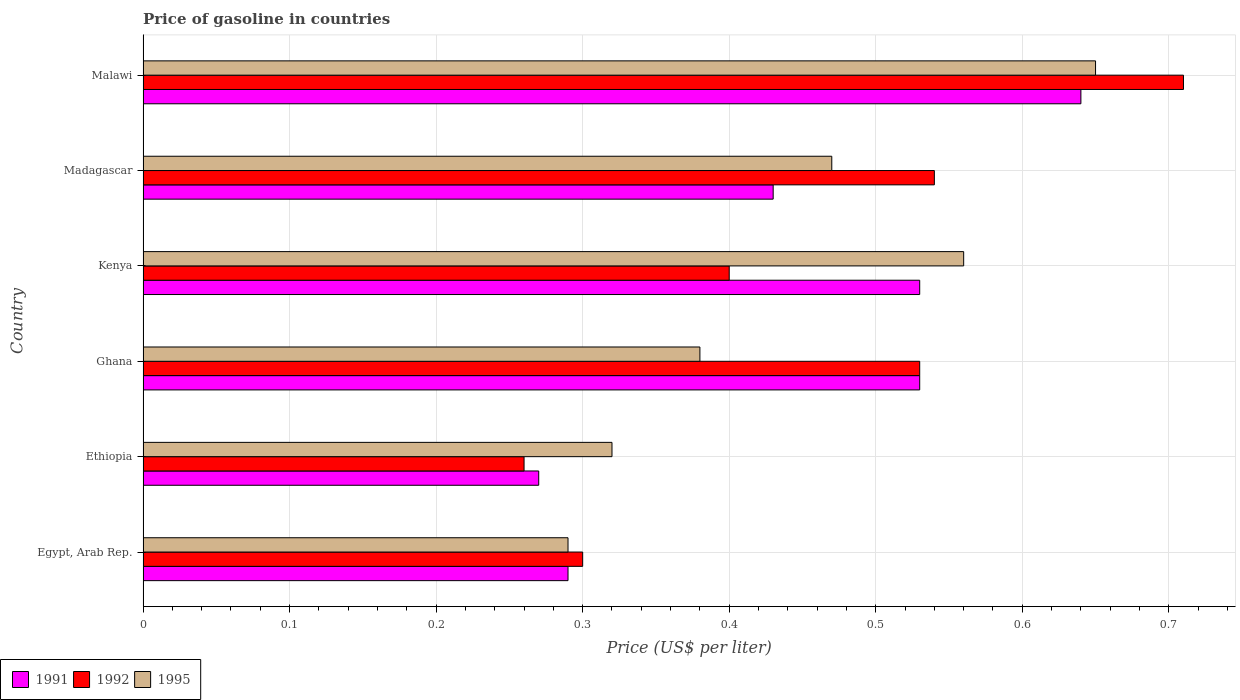How many different coloured bars are there?
Provide a short and direct response. 3. Are the number of bars per tick equal to the number of legend labels?
Provide a succinct answer. Yes. What is the label of the 5th group of bars from the top?
Provide a short and direct response. Ethiopia. In how many cases, is the number of bars for a given country not equal to the number of legend labels?
Provide a short and direct response. 0. What is the price of gasoline in 1991 in Kenya?
Your answer should be compact. 0.53. Across all countries, what is the maximum price of gasoline in 1992?
Ensure brevity in your answer.  0.71. Across all countries, what is the minimum price of gasoline in 1991?
Give a very brief answer. 0.27. In which country was the price of gasoline in 1991 maximum?
Your answer should be compact. Malawi. In which country was the price of gasoline in 1995 minimum?
Your answer should be very brief. Egypt, Arab Rep. What is the total price of gasoline in 1995 in the graph?
Provide a succinct answer. 2.67. What is the difference between the price of gasoline in 1991 in Egypt, Arab Rep. and that in Ethiopia?
Your response must be concise. 0.02. What is the difference between the price of gasoline in 1991 in Kenya and the price of gasoline in 1992 in Madagascar?
Your response must be concise. -0.01. What is the average price of gasoline in 1992 per country?
Provide a short and direct response. 0.46. What is the difference between the price of gasoline in 1991 and price of gasoline in 1992 in Ghana?
Give a very brief answer. 0. In how many countries, is the price of gasoline in 1992 greater than 0.52 US$?
Your answer should be compact. 3. What is the ratio of the price of gasoline in 1995 in Egypt, Arab Rep. to that in Ghana?
Your response must be concise. 0.76. Is the difference between the price of gasoline in 1991 in Kenya and Madagascar greater than the difference between the price of gasoline in 1992 in Kenya and Madagascar?
Keep it short and to the point. Yes. What is the difference between the highest and the second highest price of gasoline in 1991?
Ensure brevity in your answer.  0.11. What is the difference between the highest and the lowest price of gasoline in 1992?
Your answer should be compact. 0.45. What does the 3rd bar from the bottom in Ethiopia represents?
Ensure brevity in your answer.  1995. Are all the bars in the graph horizontal?
Ensure brevity in your answer.  Yes. What is the difference between two consecutive major ticks on the X-axis?
Provide a succinct answer. 0.1. Does the graph contain any zero values?
Keep it short and to the point. No. Where does the legend appear in the graph?
Make the answer very short. Bottom left. How many legend labels are there?
Provide a succinct answer. 3. How are the legend labels stacked?
Keep it short and to the point. Horizontal. What is the title of the graph?
Your response must be concise. Price of gasoline in countries. What is the label or title of the X-axis?
Provide a succinct answer. Price (US$ per liter). What is the Price (US$ per liter) of 1991 in Egypt, Arab Rep.?
Your answer should be very brief. 0.29. What is the Price (US$ per liter) in 1992 in Egypt, Arab Rep.?
Offer a terse response. 0.3. What is the Price (US$ per liter) of 1995 in Egypt, Arab Rep.?
Provide a short and direct response. 0.29. What is the Price (US$ per liter) in 1991 in Ethiopia?
Ensure brevity in your answer.  0.27. What is the Price (US$ per liter) in 1992 in Ethiopia?
Offer a terse response. 0.26. What is the Price (US$ per liter) of 1995 in Ethiopia?
Offer a very short reply. 0.32. What is the Price (US$ per liter) of 1991 in Ghana?
Keep it short and to the point. 0.53. What is the Price (US$ per liter) in 1992 in Ghana?
Provide a short and direct response. 0.53. What is the Price (US$ per liter) in 1995 in Ghana?
Your answer should be compact. 0.38. What is the Price (US$ per liter) of 1991 in Kenya?
Offer a very short reply. 0.53. What is the Price (US$ per liter) in 1992 in Kenya?
Your answer should be compact. 0.4. What is the Price (US$ per liter) of 1995 in Kenya?
Provide a succinct answer. 0.56. What is the Price (US$ per liter) of 1991 in Madagascar?
Provide a short and direct response. 0.43. What is the Price (US$ per liter) of 1992 in Madagascar?
Provide a short and direct response. 0.54. What is the Price (US$ per liter) of 1995 in Madagascar?
Offer a terse response. 0.47. What is the Price (US$ per liter) in 1991 in Malawi?
Ensure brevity in your answer.  0.64. What is the Price (US$ per liter) in 1992 in Malawi?
Keep it short and to the point. 0.71. What is the Price (US$ per liter) in 1995 in Malawi?
Your answer should be very brief. 0.65. Across all countries, what is the maximum Price (US$ per liter) in 1991?
Give a very brief answer. 0.64. Across all countries, what is the maximum Price (US$ per liter) in 1992?
Keep it short and to the point. 0.71. Across all countries, what is the maximum Price (US$ per liter) in 1995?
Provide a short and direct response. 0.65. Across all countries, what is the minimum Price (US$ per liter) of 1991?
Offer a very short reply. 0.27. Across all countries, what is the minimum Price (US$ per liter) in 1992?
Keep it short and to the point. 0.26. Across all countries, what is the minimum Price (US$ per liter) in 1995?
Offer a very short reply. 0.29. What is the total Price (US$ per liter) in 1991 in the graph?
Your answer should be very brief. 2.69. What is the total Price (US$ per liter) in 1992 in the graph?
Your response must be concise. 2.74. What is the total Price (US$ per liter) in 1995 in the graph?
Offer a very short reply. 2.67. What is the difference between the Price (US$ per liter) of 1992 in Egypt, Arab Rep. and that in Ethiopia?
Your response must be concise. 0.04. What is the difference between the Price (US$ per liter) of 1995 in Egypt, Arab Rep. and that in Ethiopia?
Give a very brief answer. -0.03. What is the difference between the Price (US$ per liter) in 1991 in Egypt, Arab Rep. and that in Ghana?
Offer a very short reply. -0.24. What is the difference between the Price (US$ per liter) in 1992 in Egypt, Arab Rep. and that in Ghana?
Offer a very short reply. -0.23. What is the difference between the Price (US$ per liter) in 1995 in Egypt, Arab Rep. and that in Ghana?
Your answer should be very brief. -0.09. What is the difference between the Price (US$ per liter) of 1991 in Egypt, Arab Rep. and that in Kenya?
Your answer should be compact. -0.24. What is the difference between the Price (US$ per liter) in 1992 in Egypt, Arab Rep. and that in Kenya?
Make the answer very short. -0.1. What is the difference between the Price (US$ per liter) in 1995 in Egypt, Arab Rep. and that in Kenya?
Offer a terse response. -0.27. What is the difference between the Price (US$ per liter) in 1991 in Egypt, Arab Rep. and that in Madagascar?
Provide a succinct answer. -0.14. What is the difference between the Price (US$ per liter) of 1992 in Egypt, Arab Rep. and that in Madagascar?
Make the answer very short. -0.24. What is the difference between the Price (US$ per liter) in 1995 in Egypt, Arab Rep. and that in Madagascar?
Offer a terse response. -0.18. What is the difference between the Price (US$ per liter) of 1991 in Egypt, Arab Rep. and that in Malawi?
Your response must be concise. -0.35. What is the difference between the Price (US$ per liter) in 1992 in Egypt, Arab Rep. and that in Malawi?
Make the answer very short. -0.41. What is the difference between the Price (US$ per liter) in 1995 in Egypt, Arab Rep. and that in Malawi?
Give a very brief answer. -0.36. What is the difference between the Price (US$ per liter) of 1991 in Ethiopia and that in Ghana?
Make the answer very short. -0.26. What is the difference between the Price (US$ per liter) of 1992 in Ethiopia and that in Ghana?
Your response must be concise. -0.27. What is the difference between the Price (US$ per liter) in 1995 in Ethiopia and that in Ghana?
Give a very brief answer. -0.06. What is the difference between the Price (US$ per liter) of 1991 in Ethiopia and that in Kenya?
Keep it short and to the point. -0.26. What is the difference between the Price (US$ per liter) of 1992 in Ethiopia and that in Kenya?
Your response must be concise. -0.14. What is the difference between the Price (US$ per liter) of 1995 in Ethiopia and that in Kenya?
Provide a short and direct response. -0.24. What is the difference between the Price (US$ per liter) in 1991 in Ethiopia and that in Madagascar?
Your answer should be very brief. -0.16. What is the difference between the Price (US$ per liter) in 1992 in Ethiopia and that in Madagascar?
Provide a short and direct response. -0.28. What is the difference between the Price (US$ per liter) in 1991 in Ethiopia and that in Malawi?
Offer a very short reply. -0.37. What is the difference between the Price (US$ per liter) of 1992 in Ethiopia and that in Malawi?
Provide a short and direct response. -0.45. What is the difference between the Price (US$ per liter) of 1995 in Ethiopia and that in Malawi?
Keep it short and to the point. -0.33. What is the difference between the Price (US$ per liter) of 1991 in Ghana and that in Kenya?
Your answer should be compact. 0. What is the difference between the Price (US$ per liter) of 1992 in Ghana and that in Kenya?
Your answer should be very brief. 0.13. What is the difference between the Price (US$ per liter) of 1995 in Ghana and that in Kenya?
Offer a terse response. -0.18. What is the difference between the Price (US$ per liter) in 1992 in Ghana and that in Madagascar?
Provide a short and direct response. -0.01. What is the difference between the Price (US$ per liter) of 1995 in Ghana and that in Madagascar?
Your response must be concise. -0.09. What is the difference between the Price (US$ per liter) of 1991 in Ghana and that in Malawi?
Keep it short and to the point. -0.11. What is the difference between the Price (US$ per liter) in 1992 in Ghana and that in Malawi?
Offer a terse response. -0.18. What is the difference between the Price (US$ per liter) of 1995 in Ghana and that in Malawi?
Offer a very short reply. -0.27. What is the difference between the Price (US$ per liter) of 1992 in Kenya and that in Madagascar?
Your response must be concise. -0.14. What is the difference between the Price (US$ per liter) of 1995 in Kenya and that in Madagascar?
Your response must be concise. 0.09. What is the difference between the Price (US$ per liter) in 1991 in Kenya and that in Malawi?
Your answer should be very brief. -0.11. What is the difference between the Price (US$ per liter) in 1992 in Kenya and that in Malawi?
Your response must be concise. -0.31. What is the difference between the Price (US$ per liter) in 1995 in Kenya and that in Malawi?
Provide a succinct answer. -0.09. What is the difference between the Price (US$ per liter) in 1991 in Madagascar and that in Malawi?
Provide a short and direct response. -0.21. What is the difference between the Price (US$ per liter) in 1992 in Madagascar and that in Malawi?
Provide a succinct answer. -0.17. What is the difference between the Price (US$ per liter) of 1995 in Madagascar and that in Malawi?
Offer a terse response. -0.18. What is the difference between the Price (US$ per liter) in 1991 in Egypt, Arab Rep. and the Price (US$ per liter) in 1995 in Ethiopia?
Make the answer very short. -0.03. What is the difference between the Price (US$ per liter) of 1992 in Egypt, Arab Rep. and the Price (US$ per liter) of 1995 in Ethiopia?
Your response must be concise. -0.02. What is the difference between the Price (US$ per liter) in 1991 in Egypt, Arab Rep. and the Price (US$ per liter) in 1992 in Ghana?
Provide a succinct answer. -0.24. What is the difference between the Price (US$ per liter) in 1991 in Egypt, Arab Rep. and the Price (US$ per liter) in 1995 in Ghana?
Keep it short and to the point. -0.09. What is the difference between the Price (US$ per liter) of 1992 in Egypt, Arab Rep. and the Price (US$ per liter) of 1995 in Ghana?
Give a very brief answer. -0.08. What is the difference between the Price (US$ per liter) of 1991 in Egypt, Arab Rep. and the Price (US$ per liter) of 1992 in Kenya?
Provide a short and direct response. -0.11. What is the difference between the Price (US$ per liter) in 1991 in Egypt, Arab Rep. and the Price (US$ per liter) in 1995 in Kenya?
Your answer should be very brief. -0.27. What is the difference between the Price (US$ per liter) of 1992 in Egypt, Arab Rep. and the Price (US$ per liter) of 1995 in Kenya?
Your answer should be very brief. -0.26. What is the difference between the Price (US$ per liter) in 1991 in Egypt, Arab Rep. and the Price (US$ per liter) in 1992 in Madagascar?
Provide a short and direct response. -0.25. What is the difference between the Price (US$ per liter) of 1991 in Egypt, Arab Rep. and the Price (US$ per liter) of 1995 in Madagascar?
Your answer should be compact. -0.18. What is the difference between the Price (US$ per liter) of 1992 in Egypt, Arab Rep. and the Price (US$ per liter) of 1995 in Madagascar?
Your response must be concise. -0.17. What is the difference between the Price (US$ per liter) of 1991 in Egypt, Arab Rep. and the Price (US$ per liter) of 1992 in Malawi?
Your response must be concise. -0.42. What is the difference between the Price (US$ per liter) in 1991 in Egypt, Arab Rep. and the Price (US$ per liter) in 1995 in Malawi?
Offer a terse response. -0.36. What is the difference between the Price (US$ per liter) in 1992 in Egypt, Arab Rep. and the Price (US$ per liter) in 1995 in Malawi?
Offer a terse response. -0.35. What is the difference between the Price (US$ per liter) of 1991 in Ethiopia and the Price (US$ per liter) of 1992 in Ghana?
Give a very brief answer. -0.26. What is the difference between the Price (US$ per liter) in 1991 in Ethiopia and the Price (US$ per liter) in 1995 in Ghana?
Make the answer very short. -0.11. What is the difference between the Price (US$ per liter) in 1992 in Ethiopia and the Price (US$ per liter) in 1995 in Ghana?
Keep it short and to the point. -0.12. What is the difference between the Price (US$ per liter) of 1991 in Ethiopia and the Price (US$ per liter) of 1992 in Kenya?
Offer a very short reply. -0.13. What is the difference between the Price (US$ per liter) of 1991 in Ethiopia and the Price (US$ per liter) of 1995 in Kenya?
Make the answer very short. -0.29. What is the difference between the Price (US$ per liter) in 1992 in Ethiopia and the Price (US$ per liter) in 1995 in Kenya?
Offer a very short reply. -0.3. What is the difference between the Price (US$ per liter) of 1991 in Ethiopia and the Price (US$ per liter) of 1992 in Madagascar?
Your response must be concise. -0.27. What is the difference between the Price (US$ per liter) of 1992 in Ethiopia and the Price (US$ per liter) of 1995 in Madagascar?
Give a very brief answer. -0.21. What is the difference between the Price (US$ per liter) of 1991 in Ethiopia and the Price (US$ per liter) of 1992 in Malawi?
Ensure brevity in your answer.  -0.44. What is the difference between the Price (US$ per liter) of 1991 in Ethiopia and the Price (US$ per liter) of 1995 in Malawi?
Offer a terse response. -0.38. What is the difference between the Price (US$ per liter) in 1992 in Ethiopia and the Price (US$ per liter) in 1995 in Malawi?
Offer a very short reply. -0.39. What is the difference between the Price (US$ per liter) of 1991 in Ghana and the Price (US$ per liter) of 1992 in Kenya?
Give a very brief answer. 0.13. What is the difference between the Price (US$ per liter) of 1991 in Ghana and the Price (US$ per liter) of 1995 in Kenya?
Give a very brief answer. -0.03. What is the difference between the Price (US$ per liter) in 1992 in Ghana and the Price (US$ per liter) in 1995 in Kenya?
Offer a very short reply. -0.03. What is the difference between the Price (US$ per liter) of 1991 in Ghana and the Price (US$ per liter) of 1992 in Madagascar?
Your answer should be very brief. -0.01. What is the difference between the Price (US$ per liter) in 1991 in Ghana and the Price (US$ per liter) in 1992 in Malawi?
Give a very brief answer. -0.18. What is the difference between the Price (US$ per liter) in 1991 in Ghana and the Price (US$ per liter) in 1995 in Malawi?
Provide a short and direct response. -0.12. What is the difference between the Price (US$ per liter) of 1992 in Ghana and the Price (US$ per liter) of 1995 in Malawi?
Your answer should be compact. -0.12. What is the difference between the Price (US$ per liter) of 1991 in Kenya and the Price (US$ per liter) of 1992 in Madagascar?
Offer a terse response. -0.01. What is the difference between the Price (US$ per liter) of 1991 in Kenya and the Price (US$ per liter) of 1995 in Madagascar?
Your answer should be very brief. 0.06. What is the difference between the Price (US$ per liter) in 1992 in Kenya and the Price (US$ per liter) in 1995 in Madagascar?
Give a very brief answer. -0.07. What is the difference between the Price (US$ per liter) in 1991 in Kenya and the Price (US$ per liter) in 1992 in Malawi?
Your response must be concise. -0.18. What is the difference between the Price (US$ per liter) of 1991 in Kenya and the Price (US$ per liter) of 1995 in Malawi?
Give a very brief answer. -0.12. What is the difference between the Price (US$ per liter) in 1992 in Kenya and the Price (US$ per liter) in 1995 in Malawi?
Your answer should be compact. -0.25. What is the difference between the Price (US$ per liter) in 1991 in Madagascar and the Price (US$ per liter) in 1992 in Malawi?
Your answer should be compact. -0.28. What is the difference between the Price (US$ per liter) of 1991 in Madagascar and the Price (US$ per liter) of 1995 in Malawi?
Offer a very short reply. -0.22. What is the difference between the Price (US$ per liter) in 1992 in Madagascar and the Price (US$ per liter) in 1995 in Malawi?
Provide a succinct answer. -0.11. What is the average Price (US$ per liter) in 1991 per country?
Ensure brevity in your answer.  0.45. What is the average Price (US$ per liter) of 1992 per country?
Provide a short and direct response. 0.46. What is the average Price (US$ per liter) of 1995 per country?
Offer a terse response. 0.45. What is the difference between the Price (US$ per liter) of 1991 and Price (US$ per liter) of 1992 in Egypt, Arab Rep.?
Offer a very short reply. -0.01. What is the difference between the Price (US$ per liter) of 1991 and Price (US$ per liter) of 1995 in Egypt, Arab Rep.?
Your response must be concise. 0. What is the difference between the Price (US$ per liter) in 1992 and Price (US$ per liter) in 1995 in Egypt, Arab Rep.?
Make the answer very short. 0.01. What is the difference between the Price (US$ per liter) in 1991 and Price (US$ per liter) in 1992 in Ethiopia?
Provide a succinct answer. 0.01. What is the difference between the Price (US$ per liter) of 1991 and Price (US$ per liter) of 1995 in Ethiopia?
Give a very brief answer. -0.05. What is the difference between the Price (US$ per liter) in 1992 and Price (US$ per liter) in 1995 in Ethiopia?
Your answer should be compact. -0.06. What is the difference between the Price (US$ per liter) of 1991 and Price (US$ per liter) of 1992 in Ghana?
Give a very brief answer. 0. What is the difference between the Price (US$ per liter) of 1991 and Price (US$ per liter) of 1995 in Ghana?
Give a very brief answer. 0.15. What is the difference between the Price (US$ per liter) of 1992 and Price (US$ per liter) of 1995 in Ghana?
Give a very brief answer. 0.15. What is the difference between the Price (US$ per liter) in 1991 and Price (US$ per liter) in 1992 in Kenya?
Ensure brevity in your answer.  0.13. What is the difference between the Price (US$ per liter) of 1991 and Price (US$ per liter) of 1995 in Kenya?
Your answer should be compact. -0.03. What is the difference between the Price (US$ per liter) of 1992 and Price (US$ per liter) of 1995 in Kenya?
Offer a very short reply. -0.16. What is the difference between the Price (US$ per liter) of 1991 and Price (US$ per liter) of 1992 in Madagascar?
Ensure brevity in your answer.  -0.11. What is the difference between the Price (US$ per liter) of 1991 and Price (US$ per liter) of 1995 in Madagascar?
Offer a terse response. -0.04. What is the difference between the Price (US$ per liter) in 1992 and Price (US$ per liter) in 1995 in Madagascar?
Offer a very short reply. 0.07. What is the difference between the Price (US$ per liter) in 1991 and Price (US$ per liter) in 1992 in Malawi?
Give a very brief answer. -0.07. What is the difference between the Price (US$ per liter) in 1991 and Price (US$ per liter) in 1995 in Malawi?
Your response must be concise. -0.01. What is the difference between the Price (US$ per liter) in 1992 and Price (US$ per liter) in 1995 in Malawi?
Keep it short and to the point. 0.06. What is the ratio of the Price (US$ per liter) in 1991 in Egypt, Arab Rep. to that in Ethiopia?
Ensure brevity in your answer.  1.07. What is the ratio of the Price (US$ per liter) of 1992 in Egypt, Arab Rep. to that in Ethiopia?
Provide a short and direct response. 1.15. What is the ratio of the Price (US$ per liter) of 1995 in Egypt, Arab Rep. to that in Ethiopia?
Provide a succinct answer. 0.91. What is the ratio of the Price (US$ per liter) in 1991 in Egypt, Arab Rep. to that in Ghana?
Ensure brevity in your answer.  0.55. What is the ratio of the Price (US$ per liter) of 1992 in Egypt, Arab Rep. to that in Ghana?
Offer a very short reply. 0.57. What is the ratio of the Price (US$ per liter) of 1995 in Egypt, Arab Rep. to that in Ghana?
Ensure brevity in your answer.  0.76. What is the ratio of the Price (US$ per liter) in 1991 in Egypt, Arab Rep. to that in Kenya?
Offer a terse response. 0.55. What is the ratio of the Price (US$ per liter) of 1992 in Egypt, Arab Rep. to that in Kenya?
Your answer should be compact. 0.75. What is the ratio of the Price (US$ per liter) in 1995 in Egypt, Arab Rep. to that in Kenya?
Your answer should be compact. 0.52. What is the ratio of the Price (US$ per liter) in 1991 in Egypt, Arab Rep. to that in Madagascar?
Provide a succinct answer. 0.67. What is the ratio of the Price (US$ per liter) of 1992 in Egypt, Arab Rep. to that in Madagascar?
Your answer should be very brief. 0.56. What is the ratio of the Price (US$ per liter) in 1995 in Egypt, Arab Rep. to that in Madagascar?
Give a very brief answer. 0.62. What is the ratio of the Price (US$ per liter) in 1991 in Egypt, Arab Rep. to that in Malawi?
Your response must be concise. 0.45. What is the ratio of the Price (US$ per liter) of 1992 in Egypt, Arab Rep. to that in Malawi?
Ensure brevity in your answer.  0.42. What is the ratio of the Price (US$ per liter) in 1995 in Egypt, Arab Rep. to that in Malawi?
Give a very brief answer. 0.45. What is the ratio of the Price (US$ per liter) in 1991 in Ethiopia to that in Ghana?
Give a very brief answer. 0.51. What is the ratio of the Price (US$ per liter) of 1992 in Ethiopia to that in Ghana?
Your answer should be compact. 0.49. What is the ratio of the Price (US$ per liter) of 1995 in Ethiopia to that in Ghana?
Keep it short and to the point. 0.84. What is the ratio of the Price (US$ per liter) in 1991 in Ethiopia to that in Kenya?
Your answer should be very brief. 0.51. What is the ratio of the Price (US$ per liter) in 1992 in Ethiopia to that in Kenya?
Offer a terse response. 0.65. What is the ratio of the Price (US$ per liter) of 1995 in Ethiopia to that in Kenya?
Make the answer very short. 0.57. What is the ratio of the Price (US$ per liter) of 1991 in Ethiopia to that in Madagascar?
Your answer should be very brief. 0.63. What is the ratio of the Price (US$ per liter) in 1992 in Ethiopia to that in Madagascar?
Your answer should be compact. 0.48. What is the ratio of the Price (US$ per liter) in 1995 in Ethiopia to that in Madagascar?
Provide a short and direct response. 0.68. What is the ratio of the Price (US$ per liter) of 1991 in Ethiopia to that in Malawi?
Give a very brief answer. 0.42. What is the ratio of the Price (US$ per liter) in 1992 in Ethiopia to that in Malawi?
Keep it short and to the point. 0.37. What is the ratio of the Price (US$ per liter) of 1995 in Ethiopia to that in Malawi?
Offer a very short reply. 0.49. What is the ratio of the Price (US$ per liter) of 1992 in Ghana to that in Kenya?
Your response must be concise. 1.32. What is the ratio of the Price (US$ per liter) of 1995 in Ghana to that in Kenya?
Make the answer very short. 0.68. What is the ratio of the Price (US$ per liter) of 1991 in Ghana to that in Madagascar?
Offer a terse response. 1.23. What is the ratio of the Price (US$ per liter) in 1992 in Ghana to that in Madagascar?
Offer a very short reply. 0.98. What is the ratio of the Price (US$ per liter) in 1995 in Ghana to that in Madagascar?
Ensure brevity in your answer.  0.81. What is the ratio of the Price (US$ per liter) in 1991 in Ghana to that in Malawi?
Make the answer very short. 0.83. What is the ratio of the Price (US$ per liter) in 1992 in Ghana to that in Malawi?
Provide a succinct answer. 0.75. What is the ratio of the Price (US$ per liter) of 1995 in Ghana to that in Malawi?
Offer a very short reply. 0.58. What is the ratio of the Price (US$ per liter) in 1991 in Kenya to that in Madagascar?
Your response must be concise. 1.23. What is the ratio of the Price (US$ per liter) in 1992 in Kenya to that in Madagascar?
Ensure brevity in your answer.  0.74. What is the ratio of the Price (US$ per liter) in 1995 in Kenya to that in Madagascar?
Your answer should be very brief. 1.19. What is the ratio of the Price (US$ per liter) of 1991 in Kenya to that in Malawi?
Ensure brevity in your answer.  0.83. What is the ratio of the Price (US$ per liter) in 1992 in Kenya to that in Malawi?
Your answer should be compact. 0.56. What is the ratio of the Price (US$ per liter) of 1995 in Kenya to that in Malawi?
Offer a terse response. 0.86. What is the ratio of the Price (US$ per liter) of 1991 in Madagascar to that in Malawi?
Provide a short and direct response. 0.67. What is the ratio of the Price (US$ per liter) of 1992 in Madagascar to that in Malawi?
Your answer should be very brief. 0.76. What is the ratio of the Price (US$ per liter) of 1995 in Madagascar to that in Malawi?
Your response must be concise. 0.72. What is the difference between the highest and the second highest Price (US$ per liter) in 1991?
Offer a very short reply. 0.11. What is the difference between the highest and the second highest Price (US$ per liter) in 1992?
Offer a very short reply. 0.17. What is the difference between the highest and the second highest Price (US$ per liter) in 1995?
Your response must be concise. 0.09. What is the difference between the highest and the lowest Price (US$ per liter) in 1991?
Ensure brevity in your answer.  0.37. What is the difference between the highest and the lowest Price (US$ per liter) of 1992?
Make the answer very short. 0.45. What is the difference between the highest and the lowest Price (US$ per liter) of 1995?
Provide a succinct answer. 0.36. 